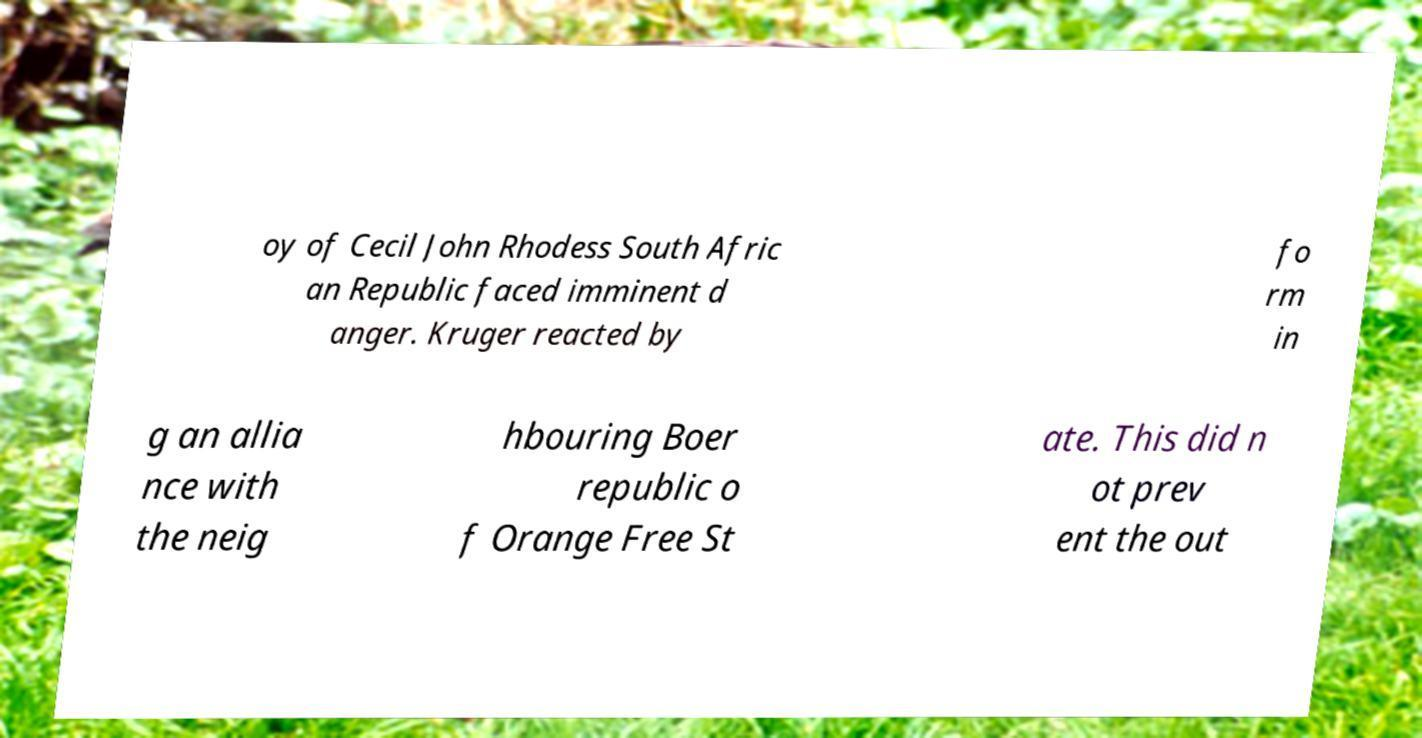What messages or text are displayed in this image? I need them in a readable, typed format. oy of Cecil John Rhodess South Afric an Republic faced imminent d anger. Kruger reacted by fo rm in g an allia nce with the neig hbouring Boer republic o f Orange Free St ate. This did n ot prev ent the out 